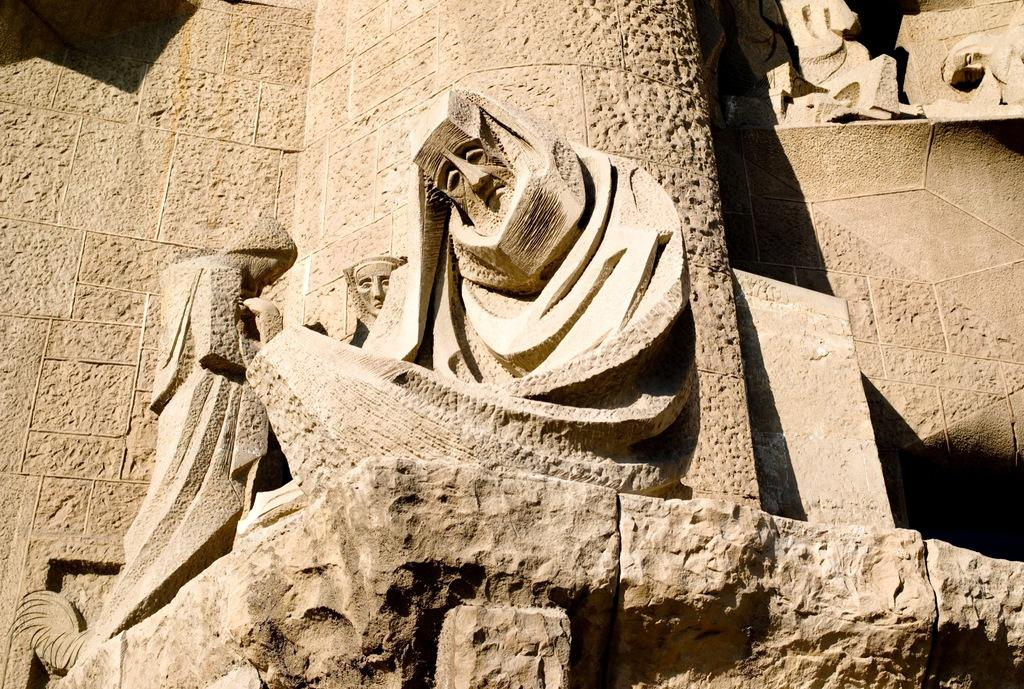What type of art is depicted in the image? There are sculptures in the image. What material are the sculptures made of? The sculptures are made of stone. What can be seen in the background of the image? There is a stone wall in the background of the image. How many toads are sitting on the stone sculptures in the image? There are no toads present in the image; the sculptures are made of stone and do not depict or include any toads. 